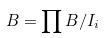Convert formula to latex. <formula><loc_0><loc_0><loc_500><loc_500>B = \prod B / I _ { i }</formula> 